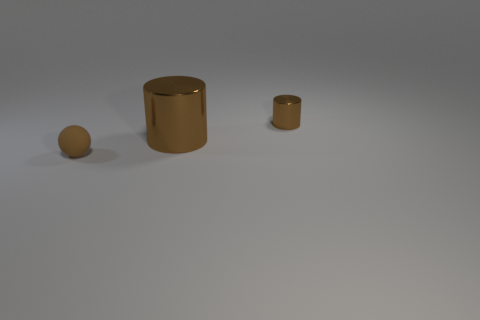What number of other things are there of the same color as the small sphere?
Offer a terse response. 2. There is a tiny brown thing in front of the tiny object right of the tiny brown rubber object; what is its material?
Keep it short and to the point. Rubber. Are there any big objects that have the same shape as the tiny brown metal object?
Provide a short and direct response. Yes. Do the brown rubber thing and the thing that is on the right side of the big brown shiny object have the same size?
Offer a terse response. Yes. How many objects are brown things that are behind the small brown ball or large cylinders that are on the right side of the tiny brown sphere?
Keep it short and to the point. 2. Are there more cylinders that are on the left side of the small brown cylinder than large purple metallic spheres?
Offer a very short reply. Yes. What number of brown metallic objects have the same size as the brown matte ball?
Your answer should be very brief. 1. Does the brown metallic cylinder in front of the tiny metallic object have the same size as the brown shiny cylinder behind the large cylinder?
Offer a very short reply. No. There is a metallic object that is in front of the small metallic cylinder; what is its size?
Your response must be concise. Large. What size is the cylinder that is to the left of the cylinder that is right of the big brown shiny thing?
Give a very brief answer. Large. 